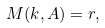<formula> <loc_0><loc_0><loc_500><loc_500>M ( k , A ) = r ,</formula> 